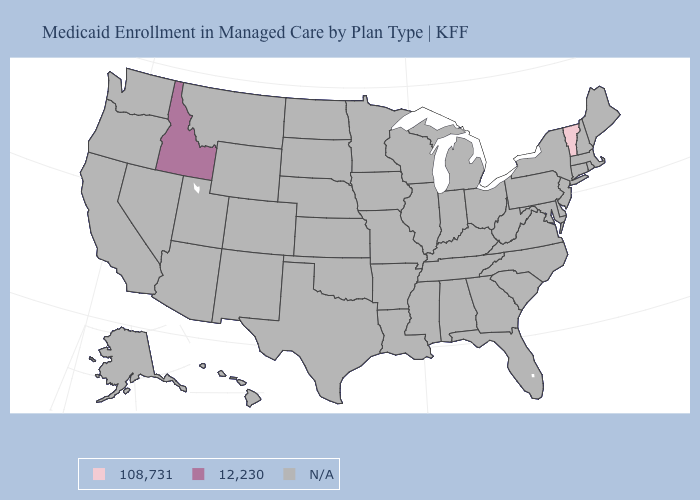Which states have the lowest value in the Northeast?
Keep it brief. Vermont. Which states have the lowest value in the USA?
Write a very short answer. Vermont. Which states have the lowest value in the USA?
Short answer required. Vermont. What is the value of Hawaii?
Be succinct. N/A. What is the highest value in the West ?
Give a very brief answer. 12,230. Name the states that have a value in the range 12,230?
Keep it brief. Idaho. What is the value of Wisconsin?
Write a very short answer. N/A. Among the states that border Massachusetts , which have the lowest value?
Short answer required. Vermont. How many symbols are there in the legend?
Concise answer only. 3. What is the value of Texas?
Write a very short answer. N/A. What is the value of Tennessee?
Answer briefly. N/A. 